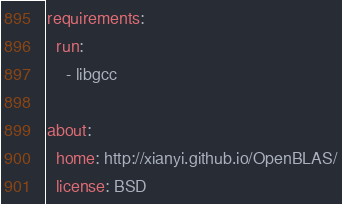Convert code to text. <code><loc_0><loc_0><loc_500><loc_500><_YAML_>
requirements:
  run:
    - libgcc

about:
  home: http://xianyi.github.io/OpenBLAS/
  license: BSD
</code> 